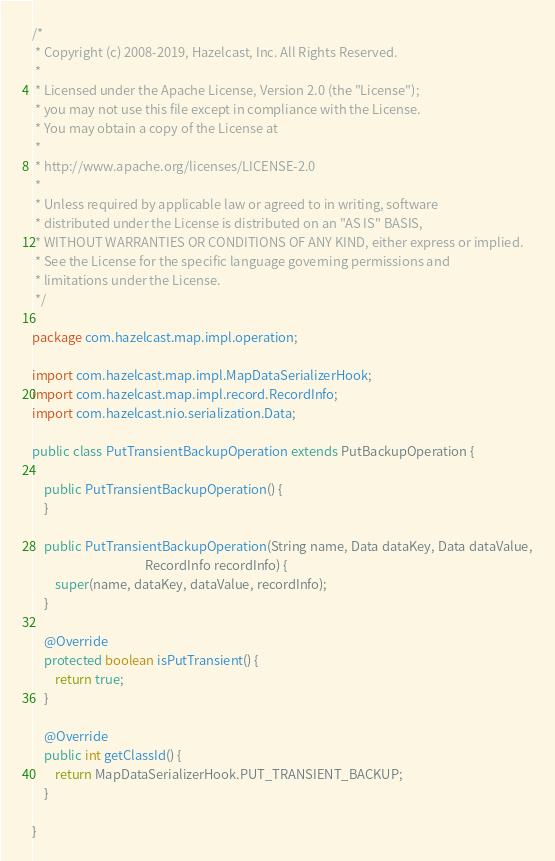<code> <loc_0><loc_0><loc_500><loc_500><_Java_>/*
 * Copyright (c) 2008-2019, Hazelcast, Inc. All Rights Reserved.
 *
 * Licensed under the Apache License, Version 2.0 (the "License");
 * you may not use this file except in compliance with the License.
 * You may obtain a copy of the License at
 *
 * http://www.apache.org/licenses/LICENSE-2.0
 *
 * Unless required by applicable law or agreed to in writing, software
 * distributed under the License is distributed on an "AS IS" BASIS,
 * WITHOUT WARRANTIES OR CONDITIONS OF ANY KIND, either express or implied.
 * See the License for the specific language governing permissions and
 * limitations under the License.
 */

package com.hazelcast.map.impl.operation;

import com.hazelcast.map.impl.MapDataSerializerHook;
import com.hazelcast.map.impl.record.RecordInfo;
import com.hazelcast.nio.serialization.Data;

public class PutTransientBackupOperation extends PutBackupOperation {

    public PutTransientBackupOperation() {
    }

    public PutTransientBackupOperation(String name, Data dataKey, Data dataValue,
                                       RecordInfo recordInfo) {
        super(name, dataKey, dataValue, recordInfo);
    }

    @Override
    protected boolean isPutTransient() {
        return true;
    }

    @Override
    public int getClassId() {
        return MapDataSerializerHook.PUT_TRANSIENT_BACKUP;
    }

}
</code> 